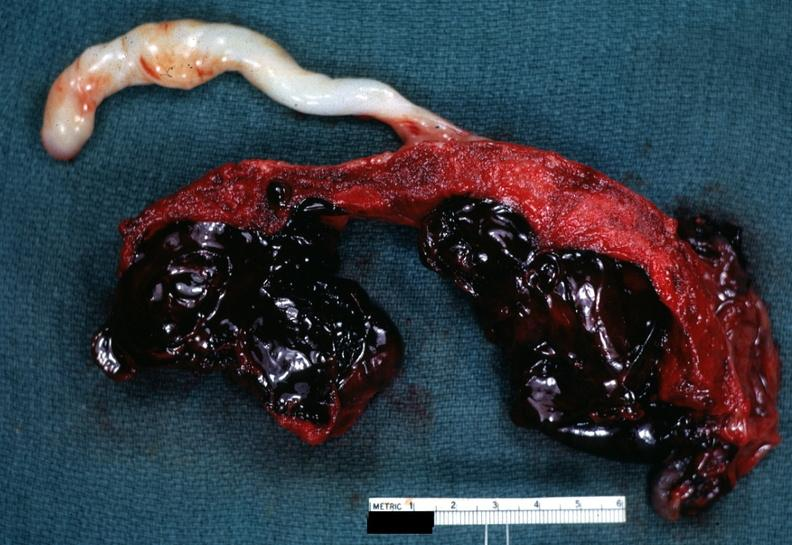s placenta present?
Answer the question using a single word or phrase. Yes 